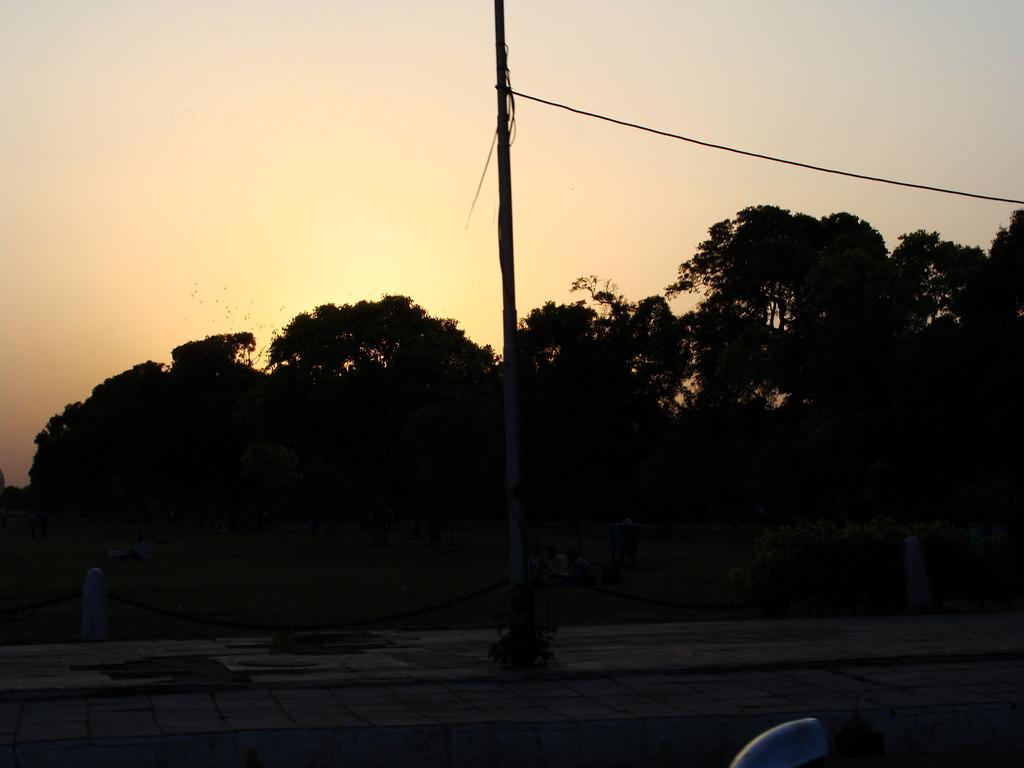What is the overall lighting condition of the image? The image is dark. What object can be seen in the image? There is a pole in the image. Who or what is present in the image? There are people in the image. What part of the environment is visible in the image? The ground is visible in the image. What type of vegetation is present in the image? There are trees in the image. What part of the natural environment is visible in the background of the image? The sky is visible in the background of the image. What type of twig can be heard reacting to the sound in the image? There is no twig or sound present in the image; it is a still image with no audio component. 